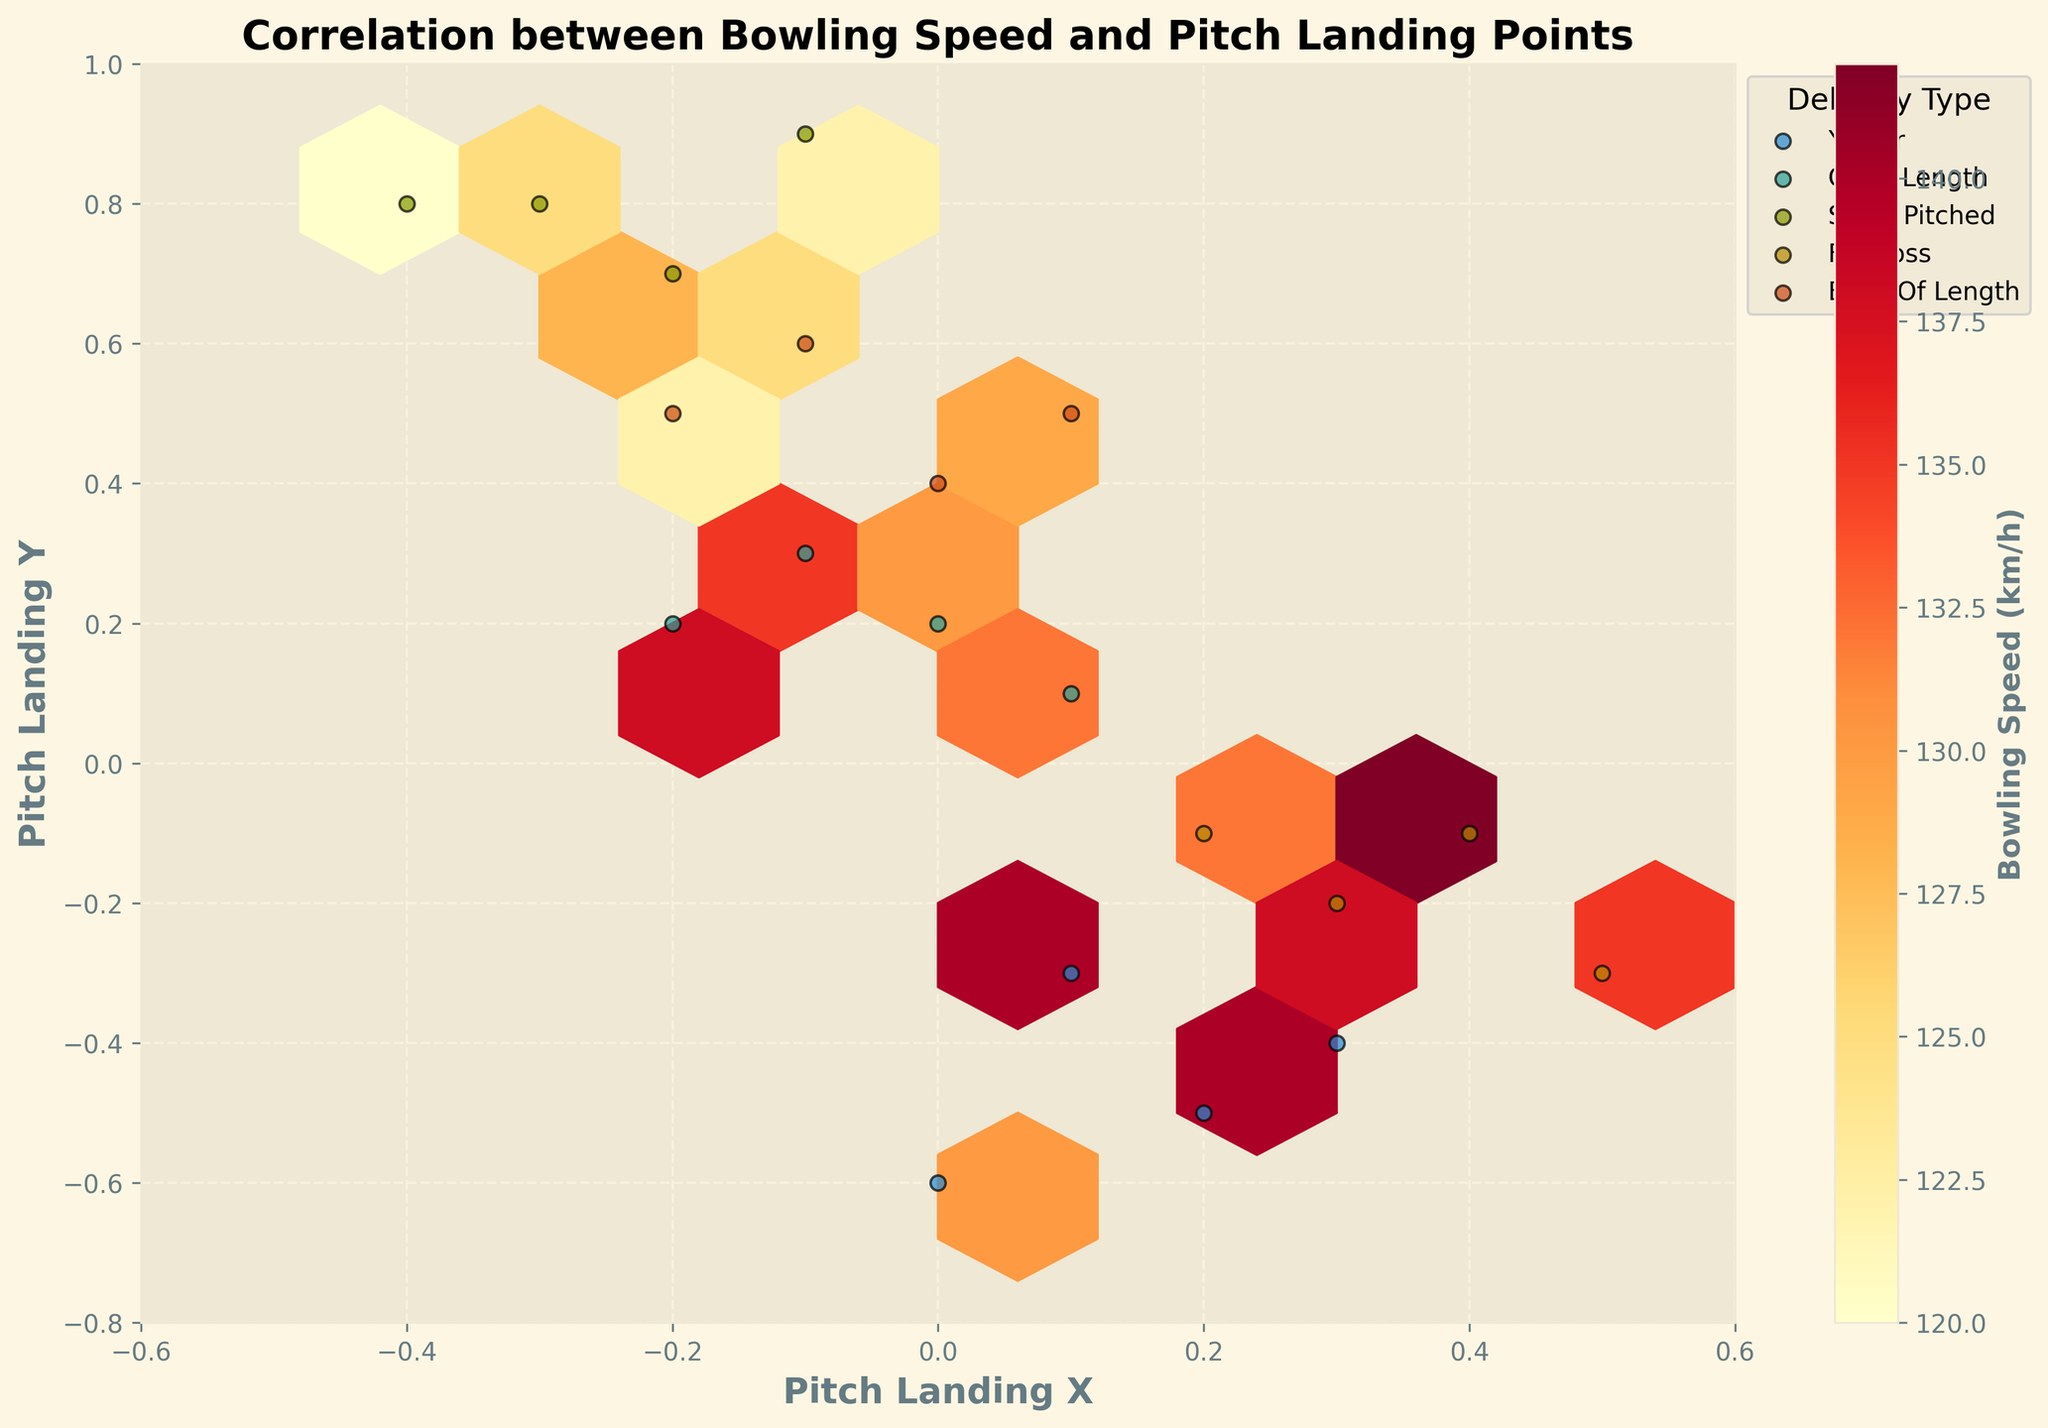What is the title of the plot? The title is found at the top center of the plot, and it summarizes the main topic of the visual information. The title reads "Correlation between Bowling Speed and Pitch Landing Points".
Answer: Correlation between Bowling Speed and Pitch Landing Points What is the color used to represent the highest bowling speed in the hexbin plot? The color representing the highest bowling speed in the hexbin plot is found in the color bar. The darkest red or deep orange on the color bar signifies the highest value.
Answer: Dark red Which delivery type appears to have the highest concentration of data points in the bottom left quadrant of the plot? Looking in the bottom left quadrant of the plot, we can identify individual data points marked by symbols related to different delivery types. The most frequent symbols in this quadrant should be identified.
Answer: Yorker What is the range of the pitch landing coordinates in the X-axis? The range of the pitch landing coordinates on the X-axis can be determined by observing the minimum and maximum values marked on the X-axis. The values range from -0.6 to 0.6.
Answer: -0.6 to 0.6 Which delivery type has data points spread most widely across the plot? To determine this, observe which delivery type symbols scatter across the largest space on the plot.
Answer: Short pitched For which value of pitch landing Y is there the highest density of hexbin cells? The highest density of hexbin cells, represented by the darkest color, should be found by observing the Y-axis and noting the Y value aligned with the most densely colored cells.
Answer: Around -0.5 Among the delivery types, which one has the highest maximum bowling speed, and what is that speed approximately? This can be answered by comparing the scatter points colored differently according to speed. Look for the delivery type with the points closest to the deepest red on the color bar.
Answer: Yorker, approximately 145 km/h Explain why yorkers might be bowled at higher speeds more often than other deliveries? Yorkers require precision and can be more effective if delivered faster, as they are aimed at the base of the stumps and can prevent the batter from hitting effectively. The plot shows yorkers generally have higher bowling speeds, likely due to this effectiveness.
Answer: Precision and effectiveness What delivery type has data points that cluster around the (0.1, -0.1) coordinate? By cross-referencing the specific coordinate with the individual delivery type markers, determine the one that clusters around that coordinate.
Answer: Full toss Which delivery type shows a negative correlation between pitch landing Y and bowling speed? Observing the trend in the hexbin density and individual data points for each type, identify if there's a type where pitch landing Y decreases as speed increases.
Answer: Yorker 